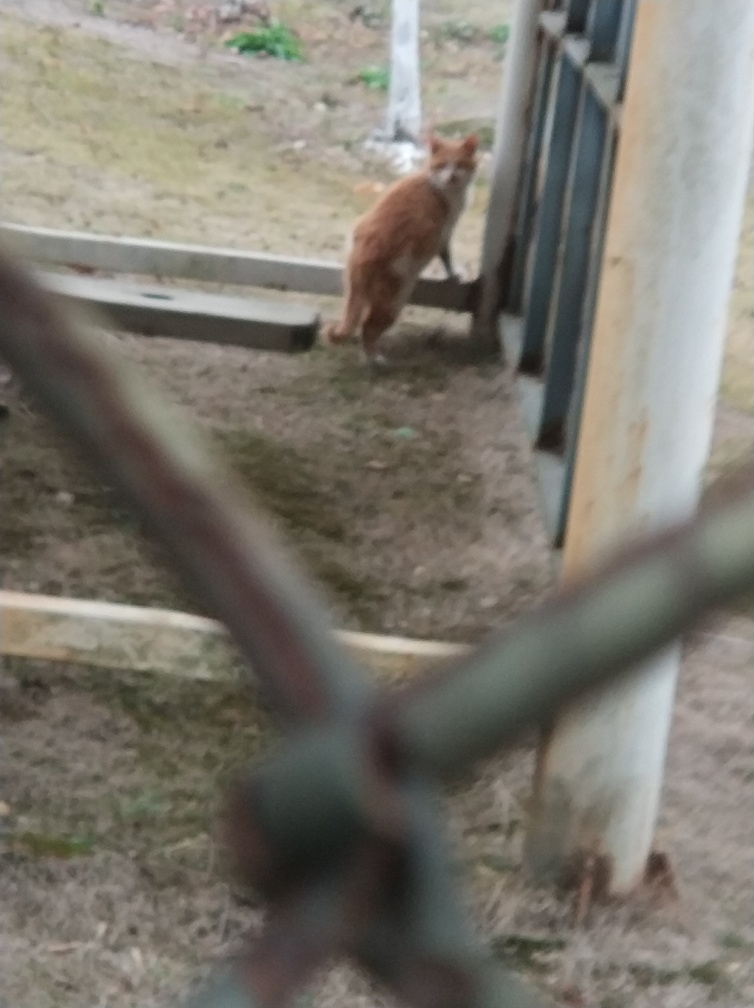Can you describe the main subject in this image? The main subject appears to be an orange cat standing beside a structure, possibly a fence or railing, with its attention directed towards the viewer. 